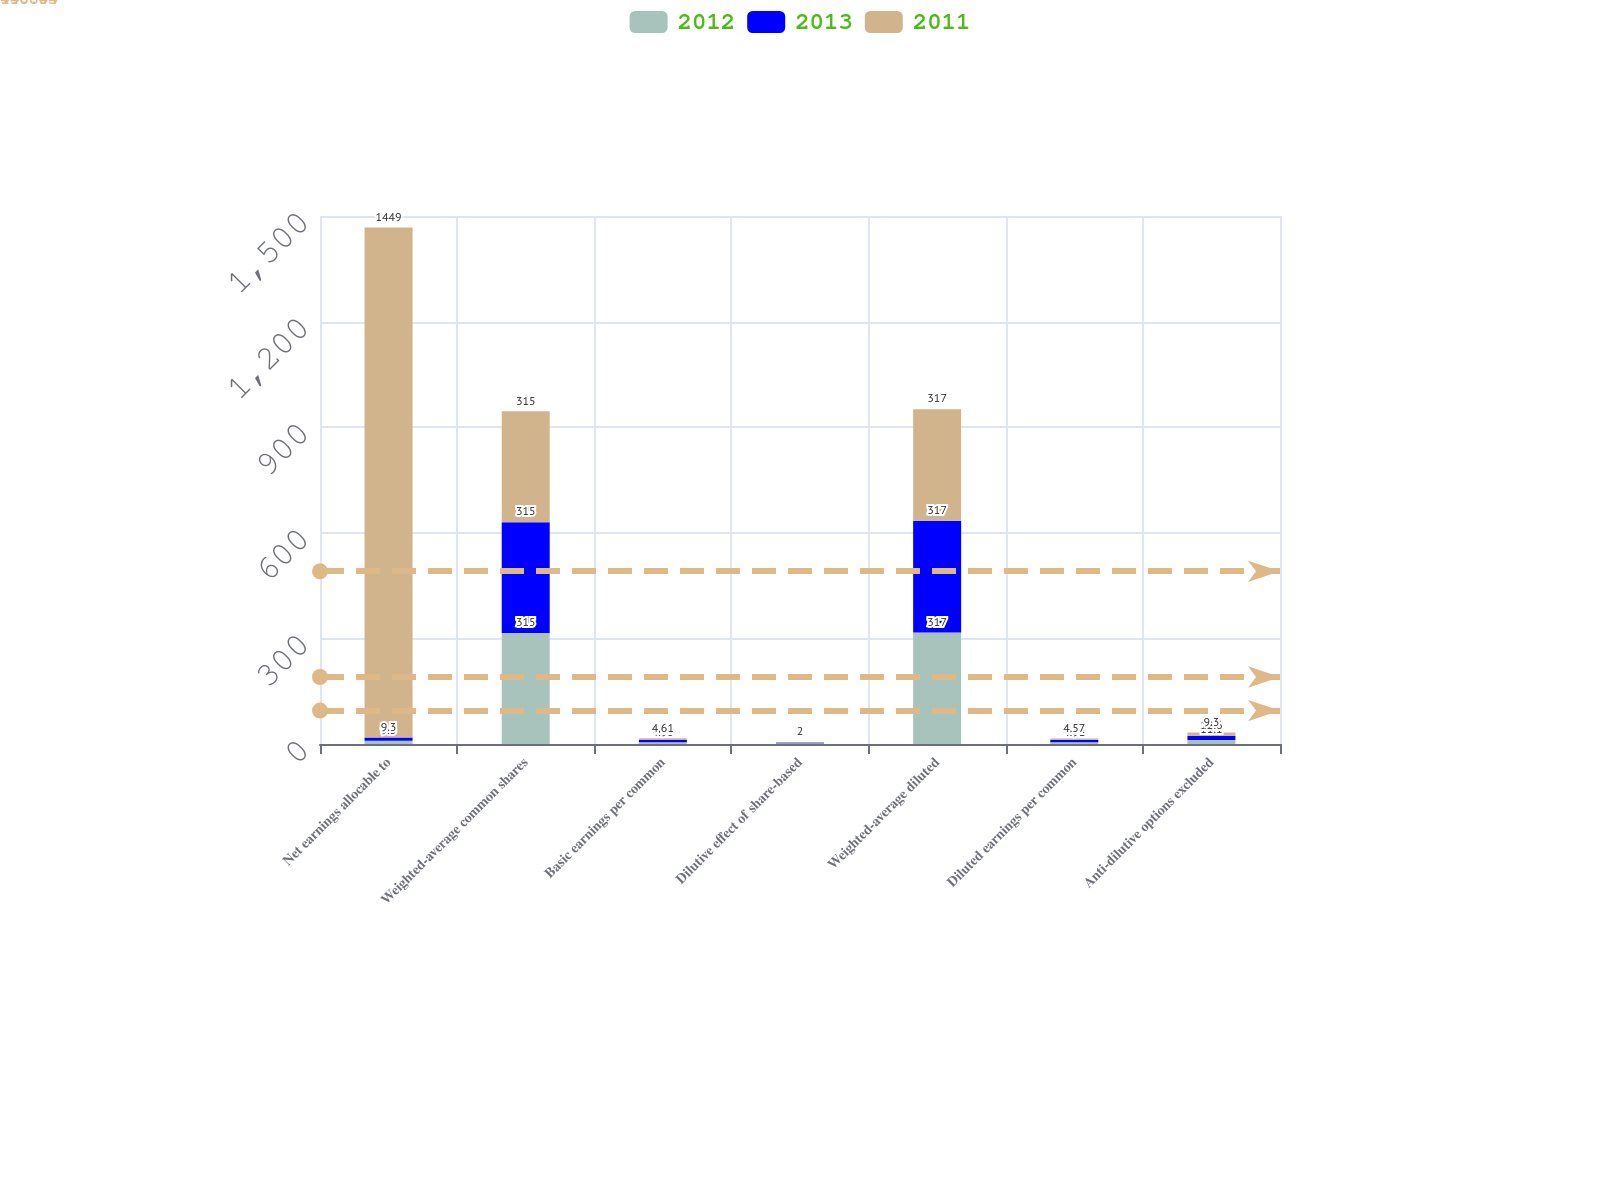Convert chart. <chart><loc_0><loc_0><loc_500><loc_500><stacked_bar_chart><ecel><fcel>Net earnings allocable to<fcel>Weighted-average common shares<fcel>Basic earnings per common<fcel>Dilutive effect of share-based<fcel>Weighted-average diluted<fcel>Diluted earnings per common<fcel>Anti-dilutive options excluded<nl><fcel>2012<fcel>9.3<fcel>315<fcel>4.95<fcel>2<fcel>317<fcel>4.91<fcel>11.1<nl><fcel>2013<fcel>9.3<fcel>315<fcel>6.44<fcel>2<fcel>317<fcel>6.41<fcel>12.6<nl><fcel>2011<fcel>1449<fcel>315<fcel>4.61<fcel>2<fcel>317<fcel>4.57<fcel>9.3<nl></chart> 